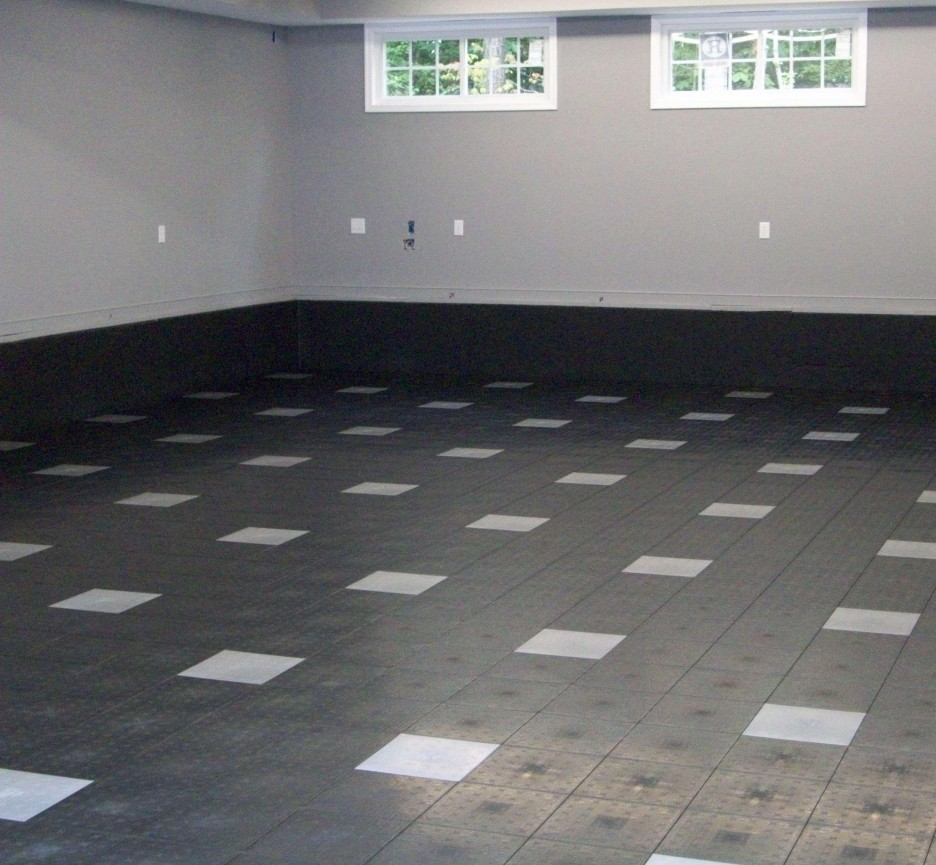How could this room be optimized for use as a creative workshop? To optimize this room for use as a creative workshop, consider integrating versatile storage solutions like shelves and cabinets to store tools and materials. Installing good artificial lighting alongside the natural light would ensure that the space is well-lit at all times, which is crucial for detailed craftwork. Adding sturdy tables and comfortable seating can provide a practical workspace. The room’s simple, clean design also allows for customizing the decor to stimulate creativity. 